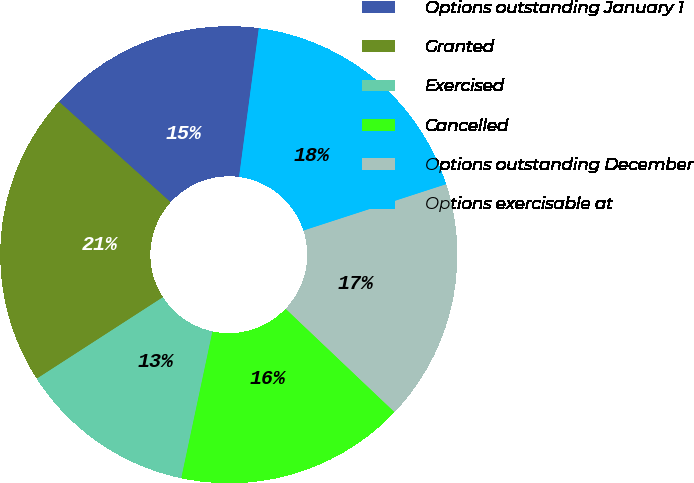Convert chart to OTSL. <chart><loc_0><loc_0><loc_500><loc_500><pie_chart><fcel>Options outstanding January 1<fcel>Granted<fcel>Exercised<fcel>Cancelled<fcel>Options outstanding December<fcel>Options exercisable at<nl><fcel>15.43%<fcel>20.8%<fcel>12.54%<fcel>16.25%<fcel>17.08%<fcel>17.9%<nl></chart> 